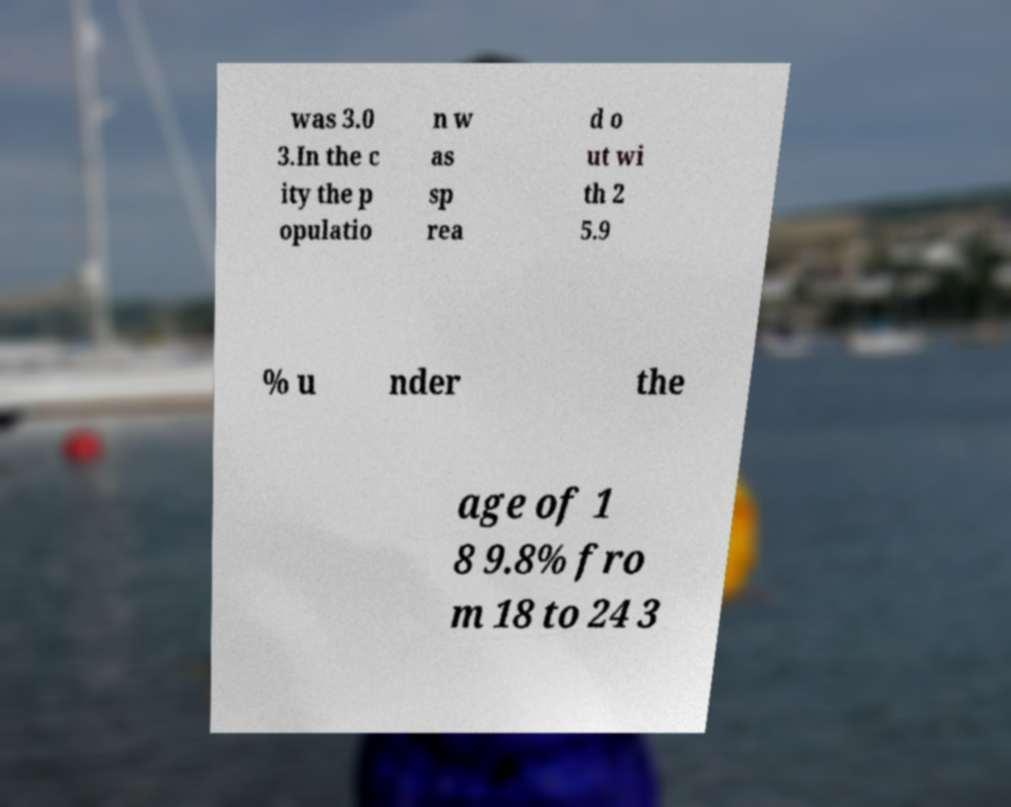Please read and relay the text visible in this image. What does it say? was 3.0 3.In the c ity the p opulatio n w as sp rea d o ut wi th 2 5.9 % u nder the age of 1 8 9.8% fro m 18 to 24 3 